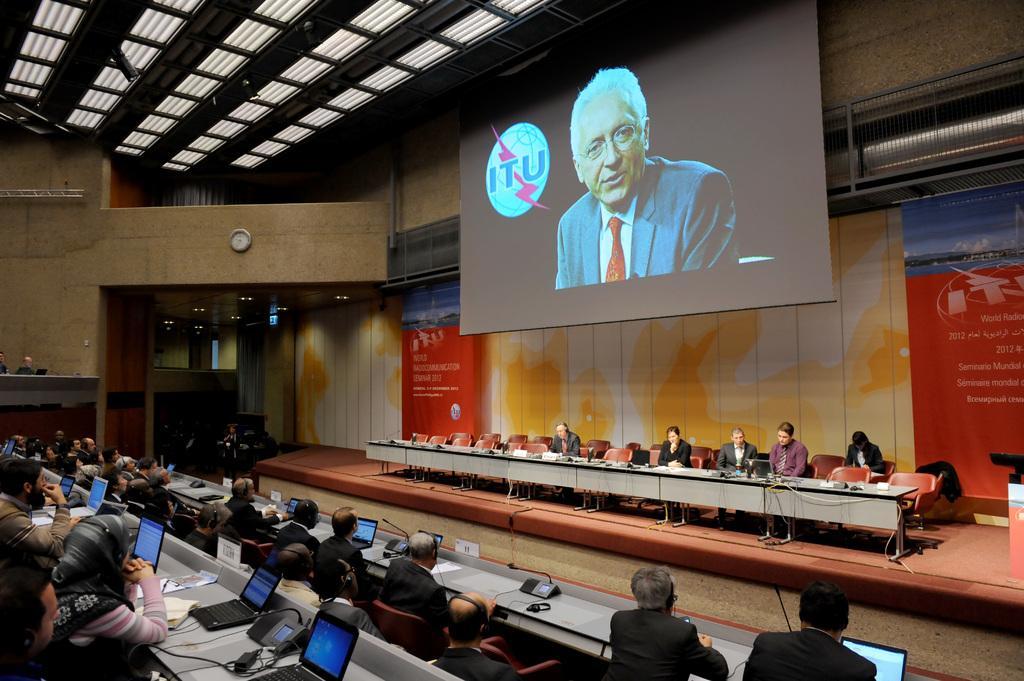Please provide a concise description of this image. In this image there is a stage on which there are tables. In front of the tables there are few people sitting in the chairs. At the top there is a screen. In front of the stage there are few people sitting in the chairs. In front of them there are laptops. At the top there is ceiling with the lights. There is a wall clock to the wall. On the stage there are two banners. 